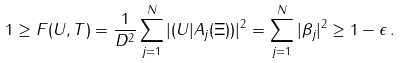Convert formula to latex. <formula><loc_0><loc_0><loc_500><loc_500>1 \geq F ( U , T ) = \frac { 1 } { D ^ { 2 } } \sum _ { j = 1 } ^ { N } | ( U | A _ { j } ( \Xi ) ) | ^ { 2 } = \sum _ { j = 1 } ^ { N } | \beta _ { j } | ^ { 2 } \geq 1 - \epsilon \, .</formula> 